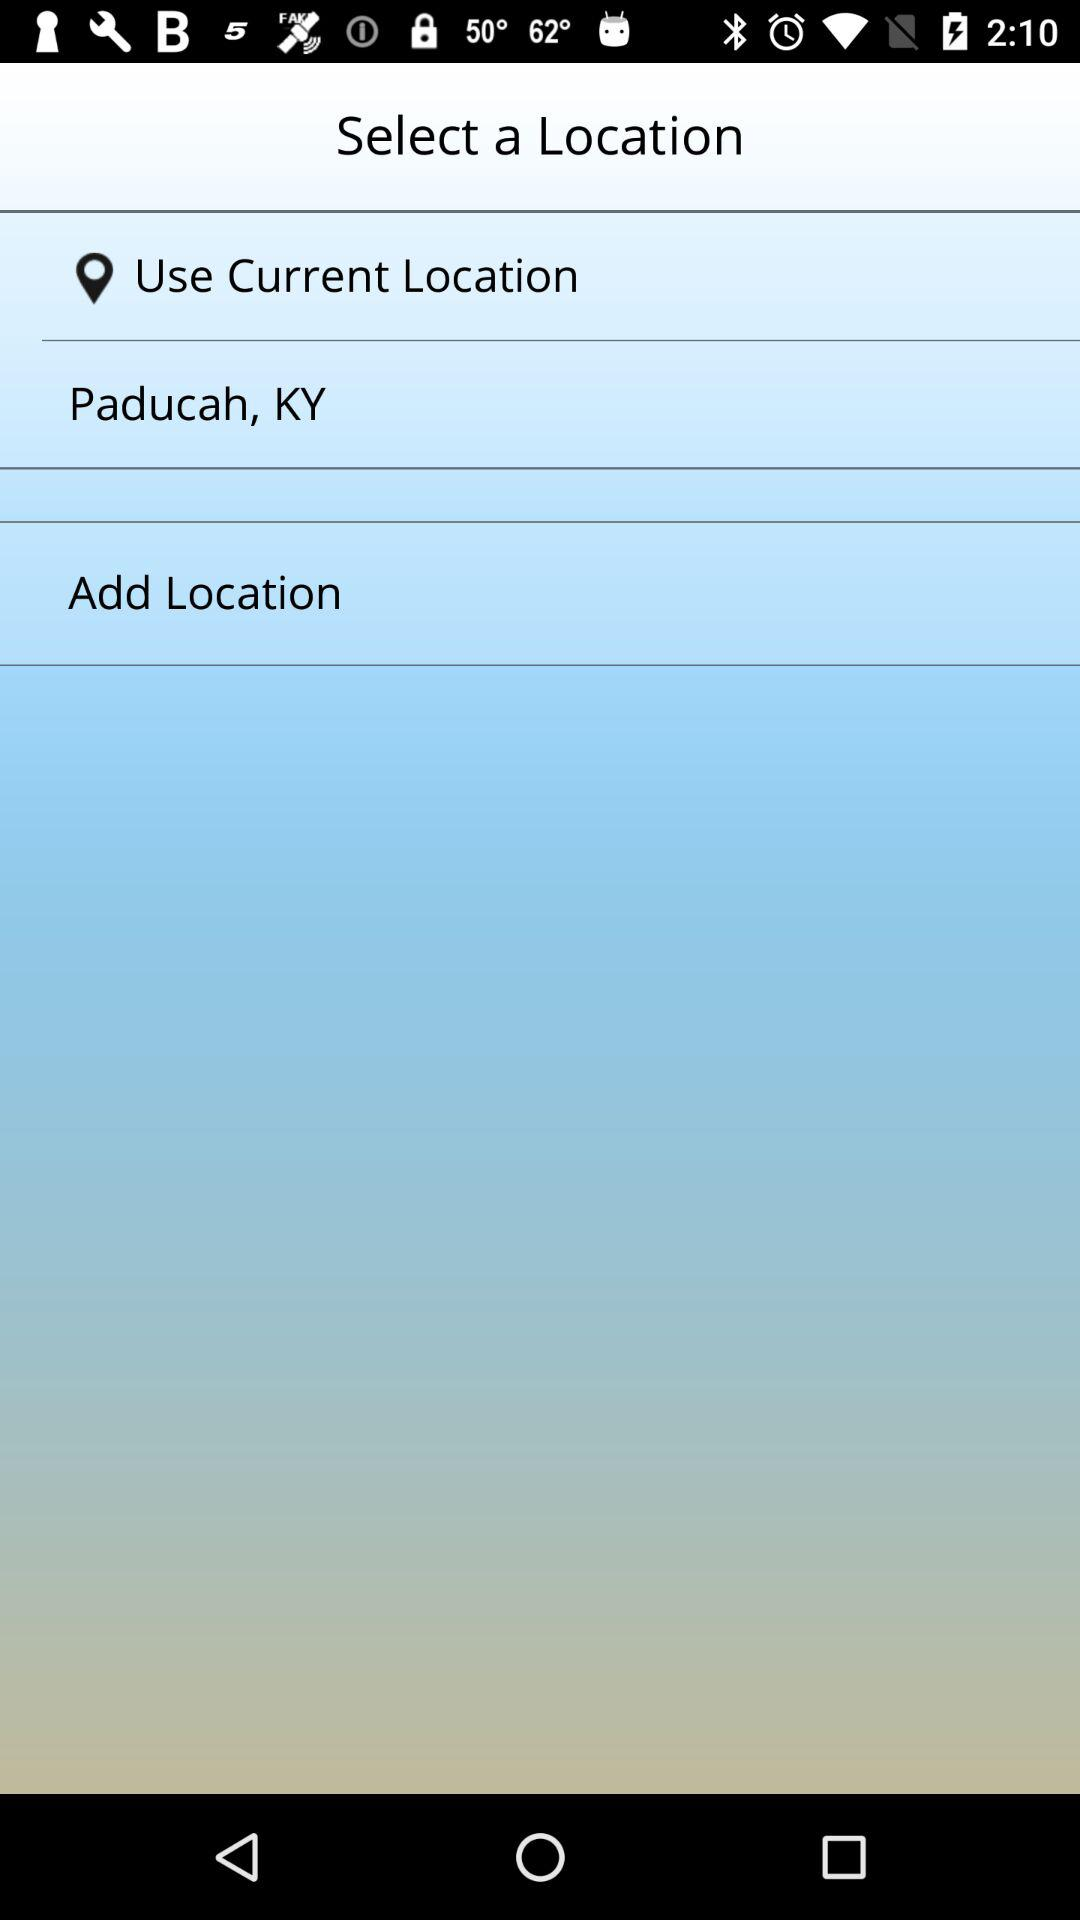How many options are there to select a location?
Answer the question using a single word or phrase. 3 